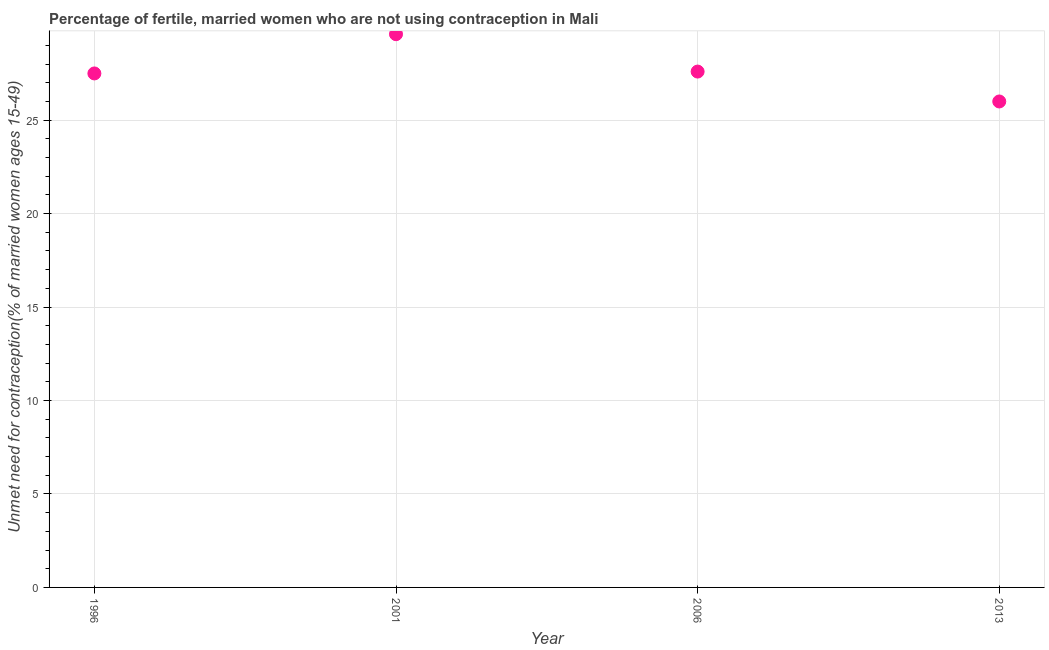What is the number of married women who are not using contraception in 1996?
Keep it short and to the point. 27.5. Across all years, what is the maximum number of married women who are not using contraception?
Your answer should be very brief. 29.6. Across all years, what is the minimum number of married women who are not using contraception?
Give a very brief answer. 26. In which year was the number of married women who are not using contraception maximum?
Make the answer very short. 2001. What is the sum of the number of married women who are not using contraception?
Ensure brevity in your answer.  110.7. What is the difference between the number of married women who are not using contraception in 2001 and 2013?
Keep it short and to the point. 3.6. What is the average number of married women who are not using contraception per year?
Your response must be concise. 27.68. What is the median number of married women who are not using contraception?
Provide a short and direct response. 27.55. What is the ratio of the number of married women who are not using contraception in 2006 to that in 2013?
Provide a succinct answer. 1.06. Is the number of married women who are not using contraception in 1996 less than that in 2001?
Provide a short and direct response. Yes. Is the sum of the number of married women who are not using contraception in 2006 and 2013 greater than the maximum number of married women who are not using contraception across all years?
Offer a terse response. Yes. What is the difference between the highest and the lowest number of married women who are not using contraception?
Offer a very short reply. 3.6. In how many years, is the number of married women who are not using contraception greater than the average number of married women who are not using contraception taken over all years?
Give a very brief answer. 1. Does the number of married women who are not using contraception monotonically increase over the years?
Provide a succinct answer. No. How many years are there in the graph?
Ensure brevity in your answer.  4. Are the values on the major ticks of Y-axis written in scientific E-notation?
Provide a succinct answer. No. Does the graph contain grids?
Offer a terse response. Yes. What is the title of the graph?
Your response must be concise. Percentage of fertile, married women who are not using contraception in Mali. What is the label or title of the Y-axis?
Make the answer very short.  Unmet need for contraception(% of married women ages 15-49). What is the  Unmet need for contraception(% of married women ages 15-49) in 2001?
Your answer should be very brief. 29.6. What is the  Unmet need for contraception(% of married women ages 15-49) in 2006?
Provide a succinct answer. 27.6. What is the  Unmet need for contraception(% of married women ages 15-49) in 2013?
Make the answer very short. 26. What is the difference between the  Unmet need for contraception(% of married women ages 15-49) in 1996 and 2013?
Provide a succinct answer. 1.5. What is the ratio of the  Unmet need for contraception(% of married women ages 15-49) in 1996 to that in 2001?
Your answer should be compact. 0.93. What is the ratio of the  Unmet need for contraception(% of married women ages 15-49) in 1996 to that in 2013?
Keep it short and to the point. 1.06. What is the ratio of the  Unmet need for contraception(% of married women ages 15-49) in 2001 to that in 2006?
Your answer should be very brief. 1.07. What is the ratio of the  Unmet need for contraception(% of married women ages 15-49) in 2001 to that in 2013?
Give a very brief answer. 1.14. What is the ratio of the  Unmet need for contraception(% of married women ages 15-49) in 2006 to that in 2013?
Offer a very short reply. 1.06. 